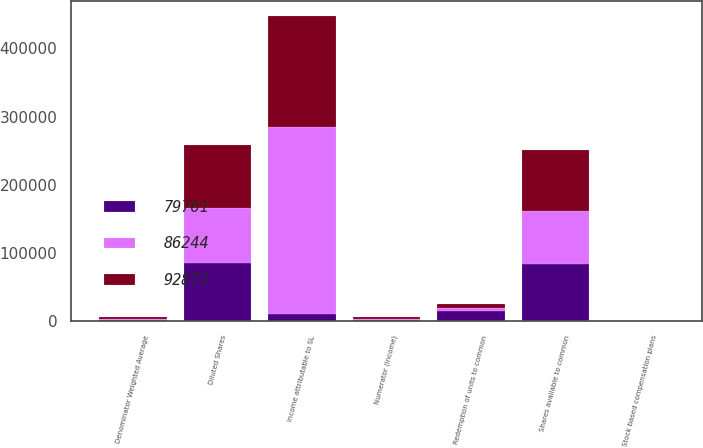<chart> <loc_0><loc_0><loc_500><loc_500><stacked_bar_chart><ecel><fcel>Numerator (Income)<fcel>Income attributable to SL<fcel>Redemption of units to common<fcel>Denominator Weighted Average<fcel>Shares available to common<fcel>Stock based compensation plans<fcel>Diluted Shares<nl><fcel>92873<fcel>2012<fcel>161581<fcel>5597<fcel>2012<fcel>89319<fcel>347<fcel>92873<nl><fcel>79761<fcel>2011<fcel>10113<fcel>14629<fcel>2011<fcel>83762<fcel>497<fcel>86244<nl><fcel>86244<fcel>2010<fcel>275400<fcel>4574<fcel>2010<fcel>78101<fcel>339<fcel>79761<nl></chart> 